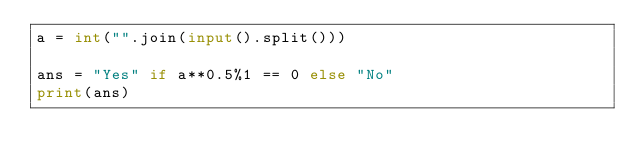<code> <loc_0><loc_0><loc_500><loc_500><_Python_>a = int("".join(input().split()))

ans = "Yes" if a**0.5%1 == 0 else "No"
print(ans)</code> 